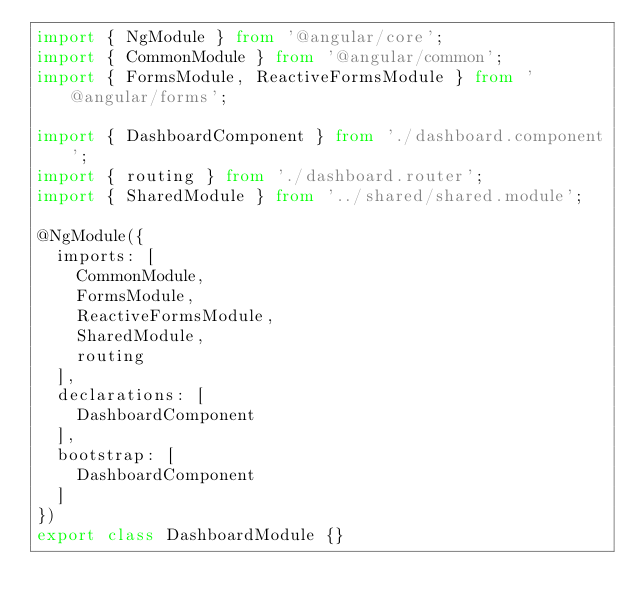Convert code to text. <code><loc_0><loc_0><loc_500><loc_500><_TypeScript_>import { NgModule } from '@angular/core';
import { CommonModule } from '@angular/common';
import { FormsModule, ReactiveFormsModule } from '@angular/forms';

import { DashboardComponent } from './dashboard.component';
import { routing } from './dashboard.router';
import { SharedModule } from '../shared/shared.module';

@NgModule({
  imports: [
    CommonModule,
    FormsModule,
    ReactiveFormsModule,
    SharedModule,
    routing
  ],
  declarations: [
    DashboardComponent
  ],
  bootstrap: [
    DashboardComponent
  ]
})
export class DashboardModule {}
</code> 